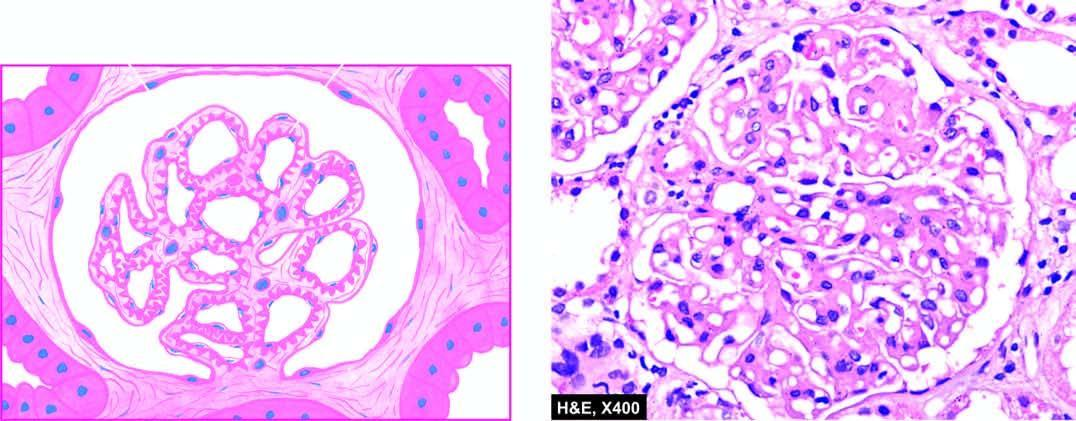what are the capillary walls diffusely thickened due to?
Answer the question using a single word or phrase. Duplication of the gbm 